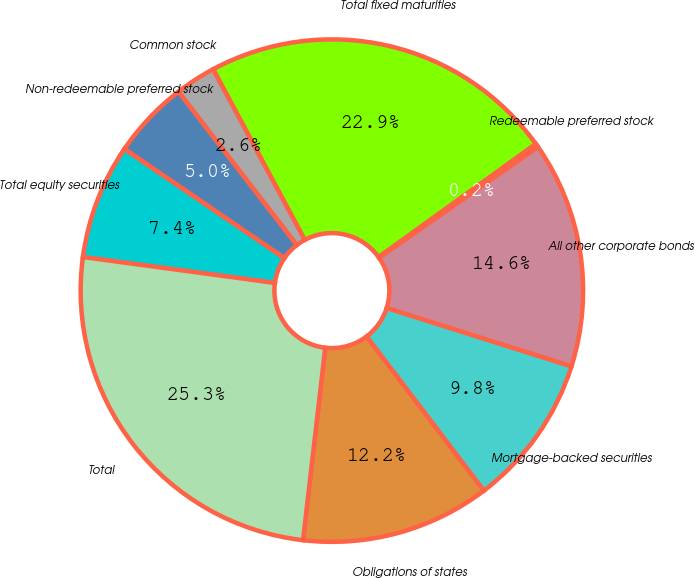Convert chart to OTSL. <chart><loc_0><loc_0><loc_500><loc_500><pie_chart><fcel>Obligations of states<fcel>Mortgage-backed securities<fcel>All other corporate bonds<fcel>Redeemable preferred stock<fcel>Total fixed maturities<fcel>Common stock<fcel>Non-redeemable preferred stock<fcel>Total equity securities<fcel>Total<nl><fcel>12.18%<fcel>9.79%<fcel>14.57%<fcel>0.23%<fcel>22.92%<fcel>2.62%<fcel>5.01%<fcel>7.4%<fcel>25.31%<nl></chart> 